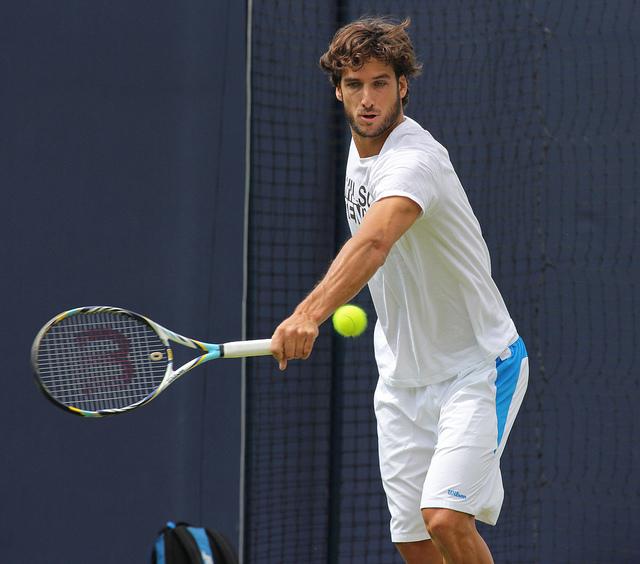Is the man swinging forehand or backhand?
Short answer required. Backhand. What letter or number is on the man's racket?
Answer briefly. W. What color is the ball?
Give a very brief answer. Yellow. 